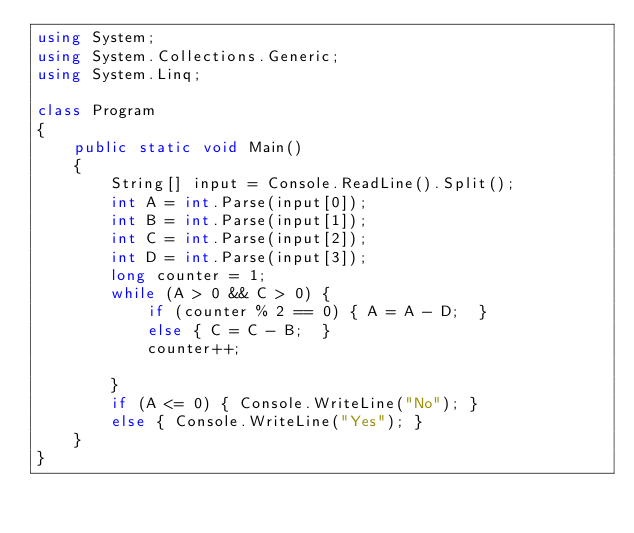Convert code to text. <code><loc_0><loc_0><loc_500><loc_500><_C#_>using System;
using System.Collections.Generic;
using System.Linq;

class Program
{
    public static void Main()
    {
        String[] input = Console.ReadLine().Split();
        int A = int.Parse(input[0]);
        int B = int.Parse(input[1]);
        int C = int.Parse(input[2]);
        int D = int.Parse(input[3]);
        long counter = 1;
        while (A > 0 && C > 0) {
            if (counter % 2 == 0) { A = A - D;  }
            else { C = C - B;  }
            counter++;
            
        }
        if (A <= 0) { Console.WriteLine("No"); }
        else { Console.WriteLine("Yes"); }
    }
}</code> 